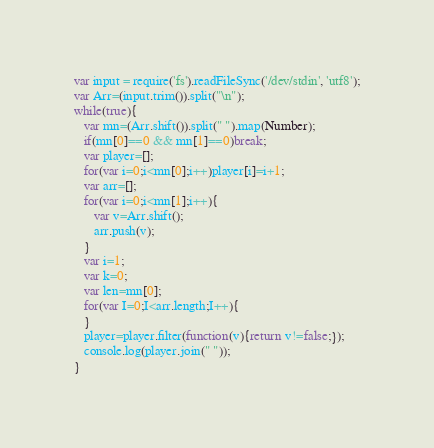<code> <loc_0><loc_0><loc_500><loc_500><_JavaScript_>var input = require('fs').readFileSync('/dev/stdin', 'utf8');
var Arr=(input.trim()).split("\n");
while(true){
   var mn=(Arr.shift()).split(" ").map(Number);
   if(mn[0]==0 && mn[1]==0)break;
   var player=[];
   for(var i=0;i<mn[0];i++)player[i]=i+1;
   var arr=[];
   for(var i=0;i<mn[1];i++){
      var v=Arr.shift();
      arr.push(v);
   }
   var i=1;
   var k=0;
   var len=mn[0];
   for(var I=0;I<arr.length;I++){
   }
   player=player.filter(function(v){return v!=false;});
   console.log(player.join(" "));
}</code> 